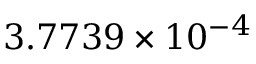<formula> <loc_0><loc_0><loc_500><loc_500>3 . 7 7 3 9 \times 1 0 ^ { - 4 }</formula> 